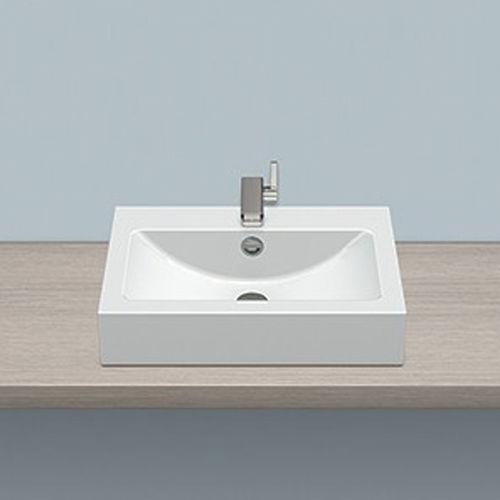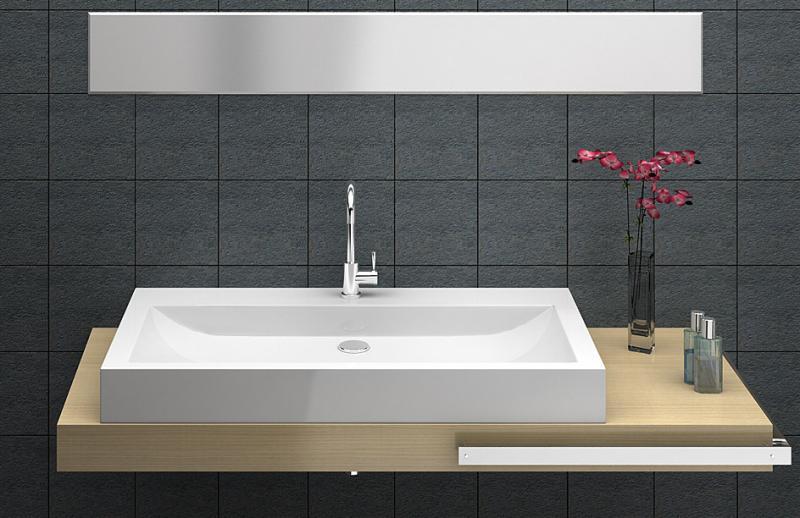The first image is the image on the left, the second image is the image on the right. Assess this claim about the two images: "Each of the sinks are attached to a black wall.". Correct or not? Answer yes or no. No. The first image is the image on the left, the second image is the image on the right. Considering the images on both sides, is "There are two rectangular sinks with faucets attached to counter tops." valid? Answer yes or no. Yes. 